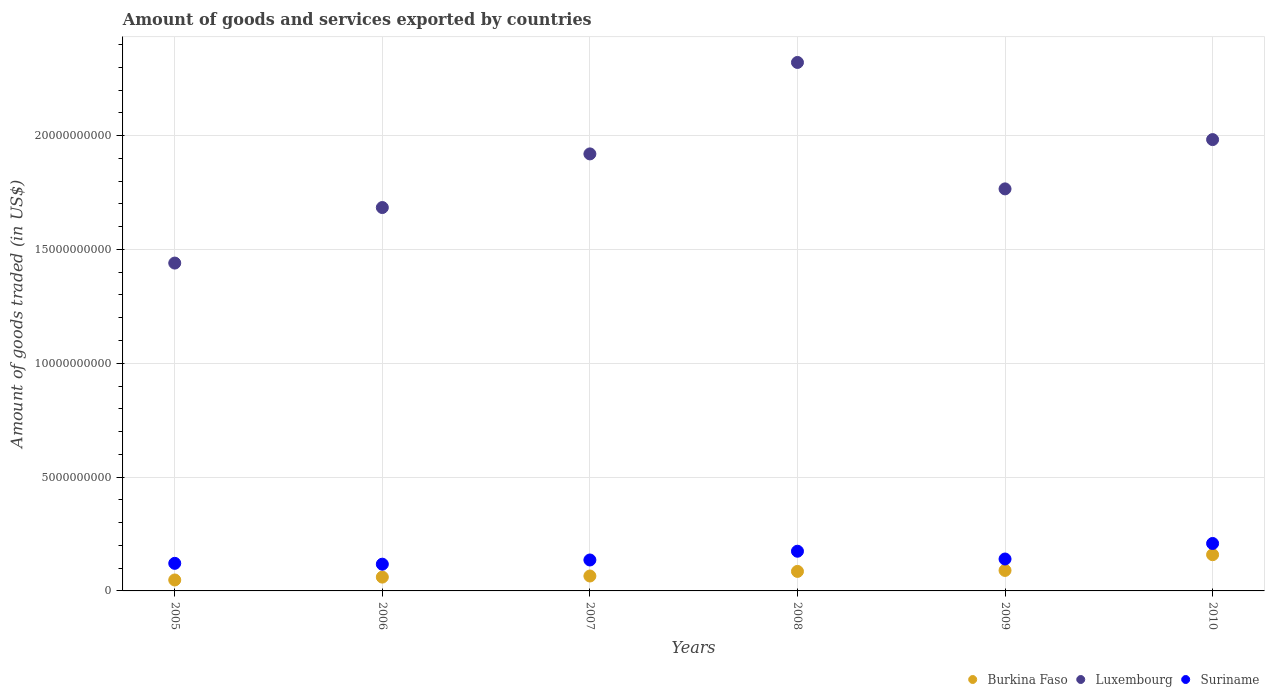Is the number of dotlines equal to the number of legend labels?
Your answer should be compact. Yes. What is the total amount of goods and services exported in Luxembourg in 2009?
Make the answer very short. 1.77e+1. Across all years, what is the maximum total amount of goods and services exported in Burkina Faso?
Your answer should be compact. 1.59e+09. Across all years, what is the minimum total amount of goods and services exported in Burkina Faso?
Give a very brief answer. 4.81e+08. In which year was the total amount of goods and services exported in Burkina Faso maximum?
Your answer should be compact. 2010. In which year was the total amount of goods and services exported in Suriname minimum?
Your answer should be very brief. 2006. What is the total total amount of goods and services exported in Suriname in the graph?
Make the answer very short. 8.97e+09. What is the difference between the total amount of goods and services exported in Burkina Faso in 2007 and that in 2010?
Ensure brevity in your answer.  -9.36e+08. What is the difference between the total amount of goods and services exported in Suriname in 2009 and the total amount of goods and services exported in Luxembourg in 2008?
Offer a very short reply. -2.18e+1. What is the average total amount of goods and services exported in Burkina Faso per year?
Your answer should be compact. 8.49e+08. In the year 2006, what is the difference between the total amount of goods and services exported in Suriname and total amount of goods and services exported in Luxembourg?
Keep it short and to the point. -1.57e+1. What is the ratio of the total amount of goods and services exported in Suriname in 2008 to that in 2009?
Keep it short and to the point. 1.24. What is the difference between the highest and the second highest total amount of goods and services exported in Burkina Faso?
Keep it short and to the point. 6.91e+08. What is the difference between the highest and the lowest total amount of goods and services exported in Burkina Faso?
Give a very brief answer. 1.11e+09. Does the total amount of goods and services exported in Burkina Faso monotonically increase over the years?
Keep it short and to the point. Yes. Is the total amount of goods and services exported in Burkina Faso strictly greater than the total amount of goods and services exported in Suriname over the years?
Provide a short and direct response. No. Is the total amount of goods and services exported in Luxembourg strictly less than the total amount of goods and services exported in Suriname over the years?
Offer a terse response. No. How many dotlines are there?
Provide a short and direct response. 3. What is the difference between two consecutive major ticks on the Y-axis?
Offer a very short reply. 5.00e+09. Are the values on the major ticks of Y-axis written in scientific E-notation?
Make the answer very short. No. Does the graph contain grids?
Your response must be concise. Yes. How are the legend labels stacked?
Provide a short and direct response. Horizontal. What is the title of the graph?
Provide a succinct answer. Amount of goods and services exported by countries. What is the label or title of the X-axis?
Make the answer very short. Years. What is the label or title of the Y-axis?
Keep it short and to the point. Amount of goods traded (in US$). What is the Amount of goods traded (in US$) of Burkina Faso in 2005?
Your answer should be very brief. 4.81e+08. What is the Amount of goods traded (in US$) of Luxembourg in 2005?
Your answer should be very brief. 1.44e+1. What is the Amount of goods traded (in US$) of Suriname in 2005?
Keep it short and to the point. 1.21e+09. What is the Amount of goods traded (in US$) in Burkina Faso in 2006?
Make the answer very short. 6.07e+08. What is the Amount of goods traded (in US$) of Luxembourg in 2006?
Make the answer very short. 1.68e+1. What is the Amount of goods traded (in US$) in Suriname in 2006?
Provide a short and direct response. 1.17e+09. What is the Amount of goods traded (in US$) in Burkina Faso in 2007?
Offer a terse response. 6.55e+08. What is the Amount of goods traded (in US$) of Luxembourg in 2007?
Offer a terse response. 1.92e+1. What is the Amount of goods traded (in US$) in Suriname in 2007?
Provide a short and direct response. 1.36e+09. What is the Amount of goods traded (in US$) of Burkina Faso in 2008?
Your answer should be compact. 8.58e+08. What is the Amount of goods traded (in US$) in Luxembourg in 2008?
Provide a succinct answer. 2.32e+1. What is the Amount of goods traded (in US$) in Suriname in 2008?
Offer a terse response. 1.74e+09. What is the Amount of goods traded (in US$) of Burkina Faso in 2009?
Provide a short and direct response. 9.00e+08. What is the Amount of goods traded (in US$) in Luxembourg in 2009?
Keep it short and to the point. 1.77e+1. What is the Amount of goods traded (in US$) of Suriname in 2009?
Keep it short and to the point. 1.40e+09. What is the Amount of goods traded (in US$) in Burkina Faso in 2010?
Your answer should be very brief. 1.59e+09. What is the Amount of goods traded (in US$) of Luxembourg in 2010?
Provide a short and direct response. 1.98e+1. What is the Amount of goods traded (in US$) in Suriname in 2010?
Offer a terse response. 2.08e+09. Across all years, what is the maximum Amount of goods traded (in US$) of Burkina Faso?
Make the answer very short. 1.59e+09. Across all years, what is the maximum Amount of goods traded (in US$) in Luxembourg?
Offer a very short reply. 2.32e+1. Across all years, what is the maximum Amount of goods traded (in US$) of Suriname?
Your answer should be compact. 2.08e+09. Across all years, what is the minimum Amount of goods traded (in US$) in Burkina Faso?
Your answer should be compact. 4.81e+08. Across all years, what is the minimum Amount of goods traded (in US$) in Luxembourg?
Give a very brief answer. 1.44e+1. Across all years, what is the minimum Amount of goods traded (in US$) of Suriname?
Your response must be concise. 1.17e+09. What is the total Amount of goods traded (in US$) in Burkina Faso in the graph?
Ensure brevity in your answer.  5.09e+09. What is the total Amount of goods traded (in US$) in Luxembourg in the graph?
Ensure brevity in your answer.  1.11e+11. What is the total Amount of goods traded (in US$) in Suriname in the graph?
Your answer should be very brief. 8.97e+09. What is the difference between the Amount of goods traded (in US$) in Burkina Faso in 2005 and that in 2006?
Keep it short and to the point. -1.26e+08. What is the difference between the Amount of goods traded (in US$) of Luxembourg in 2005 and that in 2006?
Your response must be concise. -2.44e+09. What is the difference between the Amount of goods traded (in US$) in Suriname in 2005 and that in 2006?
Give a very brief answer. 3.70e+07. What is the difference between the Amount of goods traded (in US$) in Burkina Faso in 2005 and that in 2007?
Ensure brevity in your answer.  -1.74e+08. What is the difference between the Amount of goods traded (in US$) in Luxembourg in 2005 and that in 2007?
Make the answer very short. -4.80e+09. What is the difference between the Amount of goods traded (in US$) of Suriname in 2005 and that in 2007?
Keep it short and to the point. -1.48e+08. What is the difference between the Amount of goods traded (in US$) of Burkina Faso in 2005 and that in 2008?
Offer a very short reply. -3.77e+08. What is the difference between the Amount of goods traded (in US$) of Luxembourg in 2005 and that in 2008?
Offer a terse response. -8.81e+09. What is the difference between the Amount of goods traded (in US$) of Suriname in 2005 and that in 2008?
Provide a short and direct response. -5.32e+08. What is the difference between the Amount of goods traded (in US$) in Burkina Faso in 2005 and that in 2009?
Your answer should be very brief. -4.19e+08. What is the difference between the Amount of goods traded (in US$) of Luxembourg in 2005 and that in 2009?
Keep it short and to the point. -3.26e+09. What is the difference between the Amount of goods traded (in US$) of Suriname in 2005 and that in 2009?
Your response must be concise. -1.90e+08. What is the difference between the Amount of goods traded (in US$) in Burkina Faso in 2005 and that in 2010?
Your answer should be compact. -1.11e+09. What is the difference between the Amount of goods traded (in US$) in Luxembourg in 2005 and that in 2010?
Make the answer very short. -5.42e+09. What is the difference between the Amount of goods traded (in US$) in Suriname in 2005 and that in 2010?
Offer a terse response. -8.73e+08. What is the difference between the Amount of goods traded (in US$) in Burkina Faso in 2006 and that in 2007?
Your answer should be very brief. -4.76e+07. What is the difference between the Amount of goods traded (in US$) of Luxembourg in 2006 and that in 2007?
Ensure brevity in your answer.  -2.36e+09. What is the difference between the Amount of goods traded (in US$) in Suriname in 2006 and that in 2007?
Your response must be concise. -1.84e+08. What is the difference between the Amount of goods traded (in US$) of Burkina Faso in 2006 and that in 2008?
Give a very brief answer. -2.50e+08. What is the difference between the Amount of goods traded (in US$) in Luxembourg in 2006 and that in 2008?
Offer a very short reply. -6.37e+09. What is the difference between the Amount of goods traded (in US$) in Suriname in 2006 and that in 2008?
Provide a short and direct response. -5.69e+08. What is the difference between the Amount of goods traded (in US$) in Burkina Faso in 2006 and that in 2009?
Offer a very short reply. -2.93e+08. What is the difference between the Amount of goods traded (in US$) of Luxembourg in 2006 and that in 2009?
Keep it short and to the point. -8.19e+08. What is the difference between the Amount of goods traded (in US$) of Suriname in 2006 and that in 2009?
Provide a short and direct response. -2.27e+08. What is the difference between the Amount of goods traded (in US$) in Burkina Faso in 2006 and that in 2010?
Your response must be concise. -9.84e+08. What is the difference between the Amount of goods traded (in US$) in Luxembourg in 2006 and that in 2010?
Provide a short and direct response. -2.98e+09. What is the difference between the Amount of goods traded (in US$) in Suriname in 2006 and that in 2010?
Make the answer very short. -9.10e+08. What is the difference between the Amount of goods traded (in US$) of Burkina Faso in 2007 and that in 2008?
Provide a succinct answer. -2.03e+08. What is the difference between the Amount of goods traded (in US$) in Luxembourg in 2007 and that in 2008?
Provide a short and direct response. -4.02e+09. What is the difference between the Amount of goods traded (in US$) of Suriname in 2007 and that in 2008?
Offer a very short reply. -3.84e+08. What is the difference between the Amount of goods traded (in US$) of Burkina Faso in 2007 and that in 2009?
Offer a very short reply. -2.45e+08. What is the difference between the Amount of goods traded (in US$) in Luxembourg in 2007 and that in 2009?
Provide a short and direct response. 1.54e+09. What is the difference between the Amount of goods traded (in US$) of Suriname in 2007 and that in 2009?
Keep it short and to the point. -4.28e+07. What is the difference between the Amount of goods traded (in US$) in Burkina Faso in 2007 and that in 2010?
Your answer should be very brief. -9.36e+08. What is the difference between the Amount of goods traded (in US$) of Luxembourg in 2007 and that in 2010?
Your answer should be compact. -6.28e+08. What is the difference between the Amount of goods traded (in US$) in Suriname in 2007 and that in 2010?
Ensure brevity in your answer.  -7.25e+08. What is the difference between the Amount of goods traded (in US$) in Burkina Faso in 2008 and that in 2009?
Provide a succinct answer. -4.25e+07. What is the difference between the Amount of goods traded (in US$) of Luxembourg in 2008 and that in 2009?
Give a very brief answer. 5.55e+09. What is the difference between the Amount of goods traded (in US$) in Suriname in 2008 and that in 2009?
Offer a terse response. 3.42e+08. What is the difference between the Amount of goods traded (in US$) in Burkina Faso in 2008 and that in 2010?
Your answer should be compact. -7.33e+08. What is the difference between the Amount of goods traded (in US$) of Luxembourg in 2008 and that in 2010?
Offer a terse response. 3.39e+09. What is the difference between the Amount of goods traded (in US$) of Suriname in 2008 and that in 2010?
Your answer should be compact. -3.41e+08. What is the difference between the Amount of goods traded (in US$) in Burkina Faso in 2009 and that in 2010?
Your answer should be compact. -6.91e+08. What is the difference between the Amount of goods traded (in US$) in Luxembourg in 2009 and that in 2010?
Keep it short and to the point. -2.17e+09. What is the difference between the Amount of goods traded (in US$) of Suriname in 2009 and that in 2010?
Offer a terse response. -6.82e+08. What is the difference between the Amount of goods traded (in US$) in Burkina Faso in 2005 and the Amount of goods traded (in US$) in Luxembourg in 2006?
Your response must be concise. -1.64e+1. What is the difference between the Amount of goods traded (in US$) in Burkina Faso in 2005 and the Amount of goods traded (in US$) in Suriname in 2006?
Offer a terse response. -6.94e+08. What is the difference between the Amount of goods traded (in US$) of Luxembourg in 2005 and the Amount of goods traded (in US$) of Suriname in 2006?
Your answer should be very brief. 1.32e+1. What is the difference between the Amount of goods traded (in US$) in Burkina Faso in 2005 and the Amount of goods traded (in US$) in Luxembourg in 2007?
Your response must be concise. -1.87e+1. What is the difference between the Amount of goods traded (in US$) in Burkina Faso in 2005 and the Amount of goods traded (in US$) in Suriname in 2007?
Offer a terse response. -8.78e+08. What is the difference between the Amount of goods traded (in US$) of Luxembourg in 2005 and the Amount of goods traded (in US$) of Suriname in 2007?
Provide a short and direct response. 1.30e+1. What is the difference between the Amount of goods traded (in US$) in Burkina Faso in 2005 and the Amount of goods traded (in US$) in Luxembourg in 2008?
Offer a very short reply. -2.27e+1. What is the difference between the Amount of goods traded (in US$) of Burkina Faso in 2005 and the Amount of goods traded (in US$) of Suriname in 2008?
Give a very brief answer. -1.26e+09. What is the difference between the Amount of goods traded (in US$) of Luxembourg in 2005 and the Amount of goods traded (in US$) of Suriname in 2008?
Keep it short and to the point. 1.27e+1. What is the difference between the Amount of goods traded (in US$) in Burkina Faso in 2005 and the Amount of goods traded (in US$) in Luxembourg in 2009?
Keep it short and to the point. -1.72e+1. What is the difference between the Amount of goods traded (in US$) in Burkina Faso in 2005 and the Amount of goods traded (in US$) in Suriname in 2009?
Provide a succinct answer. -9.21e+08. What is the difference between the Amount of goods traded (in US$) in Luxembourg in 2005 and the Amount of goods traded (in US$) in Suriname in 2009?
Your answer should be compact. 1.30e+1. What is the difference between the Amount of goods traded (in US$) of Burkina Faso in 2005 and the Amount of goods traded (in US$) of Luxembourg in 2010?
Offer a terse response. -1.93e+1. What is the difference between the Amount of goods traded (in US$) of Burkina Faso in 2005 and the Amount of goods traded (in US$) of Suriname in 2010?
Your response must be concise. -1.60e+09. What is the difference between the Amount of goods traded (in US$) in Luxembourg in 2005 and the Amount of goods traded (in US$) in Suriname in 2010?
Offer a terse response. 1.23e+1. What is the difference between the Amount of goods traded (in US$) in Burkina Faso in 2006 and the Amount of goods traded (in US$) in Luxembourg in 2007?
Offer a terse response. -1.86e+1. What is the difference between the Amount of goods traded (in US$) of Burkina Faso in 2006 and the Amount of goods traded (in US$) of Suriname in 2007?
Your response must be concise. -7.52e+08. What is the difference between the Amount of goods traded (in US$) in Luxembourg in 2006 and the Amount of goods traded (in US$) in Suriname in 2007?
Your answer should be compact. 1.55e+1. What is the difference between the Amount of goods traded (in US$) in Burkina Faso in 2006 and the Amount of goods traded (in US$) in Luxembourg in 2008?
Give a very brief answer. -2.26e+1. What is the difference between the Amount of goods traded (in US$) of Burkina Faso in 2006 and the Amount of goods traded (in US$) of Suriname in 2008?
Ensure brevity in your answer.  -1.14e+09. What is the difference between the Amount of goods traded (in US$) in Luxembourg in 2006 and the Amount of goods traded (in US$) in Suriname in 2008?
Provide a short and direct response. 1.51e+1. What is the difference between the Amount of goods traded (in US$) in Burkina Faso in 2006 and the Amount of goods traded (in US$) in Luxembourg in 2009?
Your answer should be very brief. -1.71e+1. What is the difference between the Amount of goods traded (in US$) in Burkina Faso in 2006 and the Amount of goods traded (in US$) in Suriname in 2009?
Provide a short and direct response. -7.95e+08. What is the difference between the Amount of goods traded (in US$) of Luxembourg in 2006 and the Amount of goods traded (in US$) of Suriname in 2009?
Give a very brief answer. 1.54e+1. What is the difference between the Amount of goods traded (in US$) of Burkina Faso in 2006 and the Amount of goods traded (in US$) of Luxembourg in 2010?
Your answer should be very brief. -1.92e+1. What is the difference between the Amount of goods traded (in US$) in Burkina Faso in 2006 and the Amount of goods traded (in US$) in Suriname in 2010?
Ensure brevity in your answer.  -1.48e+09. What is the difference between the Amount of goods traded (in US$) in Luxembourg in 2006 and the Amount of goods traded (in US$) in Suriname in 2010?
Make the answer very short. 1.48e+1. What is the difference between the Amount of goods traded (in US$) in Burkina Faso in 2007 and the Amount of goods traded (in US$) in Luxembourg in 2008?
Ensure brevity in your answer.  -2.26e+1. What is the difference between the Amount of goods traded (in US$) of Burkina Faso in 2007 and the Amount of goods traded (in US$) of Suriname in 2008?
Your response must be concise. -1.09e+09. What is the difference between the Amount of goods traded (in US$) in Luxembourg in 2007 and the Amount of goods traded (in US$) in Suriname in 2008?
Ensure brevity in your answer.  1.75e+1. What is the difference between the Amount of goods traded (in US$) of Burkina Faso in 2007 and the Amount of goods traded (in US$) of Luxembourg in 2009?
Provide a succinct answer. -1.70e+1. What is the difference between the Amount of goods traded (in US$) of Burkina Faso in 2007 and the Amount of goods traded (in US$) of Suriname in 2009?
Your answer should be very brief. -7.47e+08. What is the difference between the Amount of goods traded (in US$) of Luxembourg in 2007 and the Amount of goods traded (in US$) of Suriname in 2009?
Offer a terse response. 1.78e+1. What is the difference between the Amount of goods traded (in US$) of Burkina Faso in 2007 and the Amount of goods traded (in US$) of Luxembourg in 2010?
Provide a short and direct response. -1.92e+1. What is the difference between the Amount of goods traded (in US$) of Burkina Faso in 2007 and the Amount of goods traded (in US$) of Suriname in 2010?
Provide a short and direct response. -1.43e+09. What is the difference between the Amount of goods traded (in US$) of Luxembourg in 2007 and the Amount of goods traded (in US$) of Suriname in 2010?
Make the answer very short. 1.71e+1. What is the difference between the Amount of goods traded (in US$) in Burkina Faso in 2008 and the Amount of goods traded (in US$) in Luxembourg in 2009?
Your answer should be very brief. -1.68e+1. What is the difference between the Amount of goods traded (in US$) in Burkina Faso in 2008 and the Amount of goods traded (in US$) in Suriname in 2009?
Keep it short and to the point. -5.44e+08. What is the difference between the Amount of goods traded (in US$) of Luxembourg in 2008 and the Amount of goods traded (in US$) of Suriname in 2009?
Keep it short and to the point. 2.18e+1. What is the difference between the Amount of goods traded (in US$) of Burkina Faso in 2008 and the Amount of goods traded (in US$) of Luxembourg in 2010?
Ensure brevity in your answer.  -1.90e+1. What is the difference between the Amount of goods traded (in US$) in Burkina Faso in 2008 and the Amount of goods traded (in US$) in Suriname in 2010?
Offer a terse response. -1.23e+09. What is the difference between the Amount of goods traded (in US$) in Luxembourg in 2008 and the Amount of goods traded (in US$) in Suriname in 2010?
Offer a terse response. 2.11e+1. What is the difference between the Amount of goods traded (in US$) in Burkina Faso in 2009 and the Amount of goods traded (in US$) in Luxembourg in 2010?
Provide a succinct answer. -1.89e+1. What is the difference between the Amount of goods traded (in US$) in Burkina Faso in 2009 and the Amount of goods traded (in US$) in Suriname in 2010?
Your response must be concise. -1.18e+09. What is the difference between the Amount of goods traded (in US$) of Luxembourg in 2009 and the Amount of goods traded (in US$) of Suriname in 2010?
Offer a very short reply. 1.56e+1. What is the average Amount of goods traded (in US$) of Burkina Faso per year?
Give a very brief answer. 8.49e+08. What is the average Amount of goods traded (in US$) of Luxembourg per year?
Ensure brevity in your answer.  1.85e+1. What is the average Amount of goods traded (in US$) of Suriname per year?
Offer a very short reply. 1.50e+09. In the year 2005, what is the difference between the Amount of goods traded (in US$) of Burkina Faso and Amount of goods traded (in US$) of Luxembourg?
Provide a succinct answer. -1.39e+1. In the year 2005, what is the difference between the Amount of goods traded (in US$) of Burkina Faso and Amount of goods traded (in US$) of Suriname?
Your answer should be compact. -7.31e+08. In the year 2005, what is the difference between the Amount of goods traded (in US$) in Luxembourg and Amount of goods traded (in US$) in Suriname?
Provide a short and direct response. 1.32e+1. In the year 2006, what is the difference between the Amount of goods traded (in US$) in Burkina Faso and Amount of goods traded (in US$) in Luxembourg?
Offer a very short reply. -1.62e+1. In the year 2006, what is the difference between the Amount of goods traded (in US$) of Burkina Faso and Amount of goods traded (in US$) of Suriname?
Ensure brevity in your answer.  -5.67e+08. In the year 2006, what is the difference between the Amount of goods traded (in US$) of Luxembourg and Amount of goods traded (in US$) of Suriname?
Your answer should be compact. 1.57e+1. In the year 2007, what is the difference between the Amount of goods traded (in US$) in Burkina Faso and Amount of goods traded (in US$) in Luxembourg?
Your response must be concise. -1.85e+1. In the year 2007, what is the difference between the Amount of goods traded (in US$) in Burkina Faso and Amount of goods traded (in US$) in Suriname?
Make the answer very short. -7.04e+08. In the year 2007, what is the difference between the Amount of goods traded (in US$) of Luxembourg and Amount of goods traded (in US$) of Suriname?
Your answer should be very brief. 1.78e+1. In the year 2008, what is the difference between the Amount of goods traded (in US$) of Burkina Faso and Amount of goods traded (in US$) of Luxembourg?
Offer a very short reply. -2.24e+1. In the year 2008, what is the difference between the Amount of goods traded (in US$) in Burkina Faso and Amount of goods traded (in US$) in Suriname?
Your answer should be very brief. -8.86e+08. In the year 2008, what is the difference between the Amount of goods traded (in US$) of Luxembourg and Amount of goods traded (in US$) of Suriname?
Ensure brevity in your answer.  2.15e+1. In the year 2009, what is the difference between the Amount of goods traded (in US$) of Burkina Faso and Amount of goods traded (in US$) of Luxembourg?
Ensure brevity in your answer.  -1.68e+1. In the year 2009, what is the difference between the Amount of goods traded (in US$) in Burkina Faso and Amount of goods traded (in US$) in Suriname?
Provide a short and direct response. -5.02e+08. In the year 2009, what is the difference between the Amount of goods traded (in US$) in Luxembourg and Amount of goods traded (in US$) in Suriname?
Your response must be concise. 1.63e+1. In the year 2010, what is the difference between the Amount of goods traded (in US$) in Burkina Faso and Amount of goods traded (in US$) in Luxembourg?
Ensure brevity in your answer.  -1.82e+1. In the year 2010, what is the difference between the Amount of goods traded (in US$) of Burkina Faso and Amount of goods traded (in US$) of Suriname?
Make the answer very short. -4.93e+08. In the year 2010, what is the difference between the Amount of goods traded (in US$) in Luxembourg and Amount of goods traded (in US$) in Suriname?
Offer a terse response. 1.77e+1. What is the ratio of the Amount of goods traded (in US$) of Burkina Faso in 2005 to that in 2006?
Make the answer very short. 0.79. What is the ratio of the Amount of goods traded (in US$) of Luxembourg in 2005 to that in 2006?
Offer a terse response. 0.86. What is the ratio of the Amount of goods traded (in US$) in Suriname in 2005 to that in 2006?
Your answer should be very brief. 1.03. What is the ratio of the Amount of goods traded (in US$) in Burkina Faso in 2005 to that in 2007?
Your answer should be compact. 0.73. What is the ratio of the Amount of goods traded (in US$) of Luxembourg in 2005 to that in 2007?
Offer a terse response. 0.75. What is the ratio of the Amount of goods traded (in US$) of Suriname in 2005 to that in 2007?
Your answer should be very brief. 0.89. What is the ratio of the Amount of goods traded (in US$) of Burkina Faso in 2005 to that in 2008?
Your answer should be very brief. 0.56. What is the ratio of the Amount of goods traded (in US$) in Luxembourg in 2005 to that in 2008?
Your answer should be compact. 0.62. What is the ratio of the Amount of goods traded (in US$) of Suriname in 2005 to that in 2008?
Your answer should be compact. 0.69. What is the ratio of the Amount of goods traded (in US$) in Burkina Faso in 2005 to that in 2009?
Ensure brevity in your answer.  0.53. What is the ratio of the Amount of goods traded (in US$) in Luxembourg in 2005 to that in 2009?
Give a very brief answer. 0.82. What is the ratio of the Amount of goods traded (in US$) of Suriname in 2005 to that in 2009?
Your answer should be very brief. 0.86. What is the ratio of the Amount of goods traded (in US$) in Burkina Faso in 2005 to that in 2010?
Your answer should be compact. 0.3. What is the ratio of the Amount of goods traded (in US$) of Luxembourg in 2005 to that in 2010?
Provide a succinct answer. 0.73. What is the ratio of the Amount of goods traded (in US$) of Suriname in 2005 to that in 2010?
Offer a very short reply. 0.58. What is the ratio of the Amount of goods traded (in US$) of Burkina Faso in 2006 to that in 2007?
Make the answer very short. 0.93. What is the ratio of the Amount of goods traded (in US$) in Luxembourg in 2006 to that in 2007?
Make the answer very short. 0.88. What is the ratio of the Amount of goods traded (in US$) in Suriname in 2006 to that in 2007?
Offer a terse response. 0.86. What is the ratio of the Amount of goods traded (in US$) in Burkina Faso in 2006 to that in 2008?
Give a very brief answer. 0.71. What is the ratio of the Amount of goods traded (in US$) in Luxembourg in 2006 to that in 2008?
Keep it short and to the point. 0.73. What is the ratio of the Amount of goods traded (in US$) of Suriname in 2006 to that in 2008?
Your response must be concise. 0.67. What is the ratio of the Amount of goods traded (in US$) of Burkina Faso in 2006 to that in 2009?
Your answer should be compact. 0.67. What is the ratio of the Amount of goods traded (in US$) in Luxembourg in 2006 to that in 2009?
Provide a short and direct response. 0.95. What is the ratio of the Amount of goods traded (in US$) of Suriname in 2006 to that in 2009?
Your answer should be compact. 0.84. What is the ratio of the Amount of goods traded (in US$) in Burkina Faso in 2006 to that in 2010?
Keep it short and to the point. 0.38. What is the ratio of the Amount of goods traded (in US$) of Luxembourg in 2006 to that in 2010?
Your answer should be very brief. 0.85. What is the ratio of the Amount of goods traded (in US$) in Suriname in 2006 to that in 2010?
Your answer should be very brief. 0.56. What is the ratio of the Amount of goods traded (in US$) in Burkina Faso in 2007 to that in 2008?
Your response must be concise. 0.76. What is the ratio of the Amount of goods traded (in US$) of Luxembourg in 2007 to that in 2008?
Your answer should be compact. 0.83. What is the ratio of the Amount of goods traded (in US$) in Suriname in 2007 to that in 2008?
Offer a terse response. 0.78. What is the ratio of the Amount of goods traded (in US$) of Burkina Faso in 2007 to that in 2009?
Give a very brief answer. 0.73. What is the ratio of the Amount of goods traded (in US$) in Luxembourg in 2007 to that in 2009?
Give a very brief answer. 1.09. What is the ratio of the Amount of goods traded (in US$) of Suriname in 2007 to that in 2009?
Ensure brevity in your answer.  0.97. What is the ratio of the Amount of goods traded (in US$) of Burkina Faso in 2007 to that in 2010?
Offer a very short reply. 0.41. What is the ratio of the Amount of goods traded (in US$) in Luxembourg in 2007 to that in 2010?
Provide a succinct answer. 0.97. What is the ratio of the Amount of goods traded (in US$) of Suriname in 2007 to that in 2010?
Offer a terse response. 0.65. What is the ratio of the Amount of goods traded (in US$) of Burkina Faso in 2008 to that in 2009?
Your response must be concise. 0.95. What is the ratio of the Amount of goods traded (in US$) of Luxembourg in 2008 to that in 2009?
Keep it short and to the point. 1.31. What is the ratio of the Amount of goods traded (in US$) of Suriname in 2008 to that in 2009?
Offer a terse response. 1.24. What is the ratio of the Amount of goods traded (in US$) in Burkina Faso in 2008 to that in 2010?
Offer a terse response. 0.54. What is the ratio of the Amount of goods traded (in US$) in Luxembourg in 2008 to that in 2010?
Offer a very short reply. 1.17. What is the ratio of the Amount of goods traded (in US$) of Suriname in 2008 to that in 2010?
Offer a very short reply. 0.84. What is the ratio of the Amount of goods traded (in US$) of Burkina Faso in 2009 to that in 2010?
Offer a very short reply. 0.57. What is the ratio of the Amount of goods traded (in US$) in Luxembourg in 2009 to that in 2010?
Keep it short and to the point. 0.89. What is the ratio of the Amount of goods traded (in US$) of Suriname in 2009 to that in 2010?
Offer a terse response. 0.67. What is the difference between the highest and the second highest Amount of goods traded (in US$) in Burkina Faso?
Keep it short and to the point. 6.91e+08. What is the difference between the highest and the second highest Amount of goods traded (in US$) in Luxembourg?
Make the answer very short. 3.39e+09. What is the difference between the highest and the second highest Amount of goods traded (in US$) of Suriname?
Offer a very short reply. 3.41e+08. What is the difference between the highest and the lowest Amount of goods traded (in US$) in Burkina Faso?
Ensure brevity in your answer.  1.11e+09. What is the difference between the highest and the lowest Amount of goods traded (in US$) in Luxembourg?
Give a very brief answer. 8.81e+09. What is the difference between the highest and the lowest Amount of goods traded (in US$) of Suriname?
Offer a very short reply. 9.10e+08. 